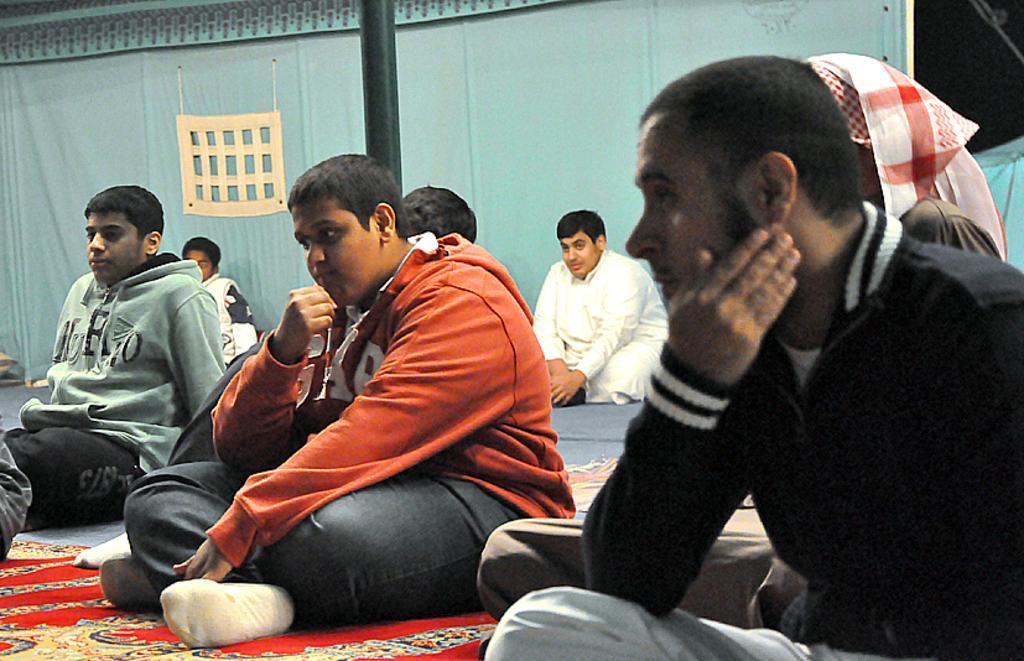In one or two sentences, can you explain what this image depicts? In this image we can see many people sitting. On the floor there is floor mat. In the back there is a cloth. Also we can see a pole. 